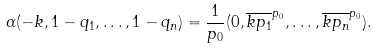Convert formula to latex. <formula><loc_0><loc_0><loc_500><loc_500>\alpha ( - k , 1 - q _ { 1 } , \dots , 1 - q _ { n } ) = \frac { 1 } { p _ { 0 } } ( 0 , \overline { k p _ { 1 } } ^ { p _ { 0 } } , \dots , \overline { k p _ { n } } ^ { p _ { 0 } } ) .</formula> 